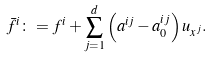Convert formula to latex. <formula><loc_0><loc_0><loc_500><loc_500>\bar { f } ^ { i } \colon = f ^ { i } + \sum _ { j = 1 } ^ { d } \left ( a ^ { i j } - a _ { 0 } ^ { i j } \right ) u _ { x ^ { j } } .</formula> 